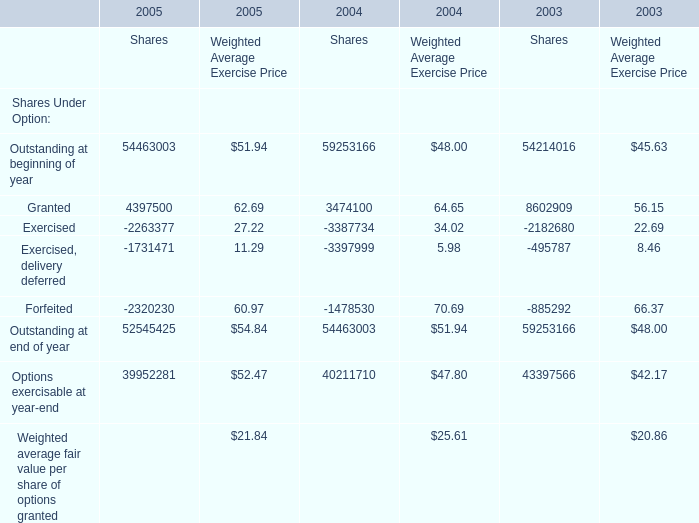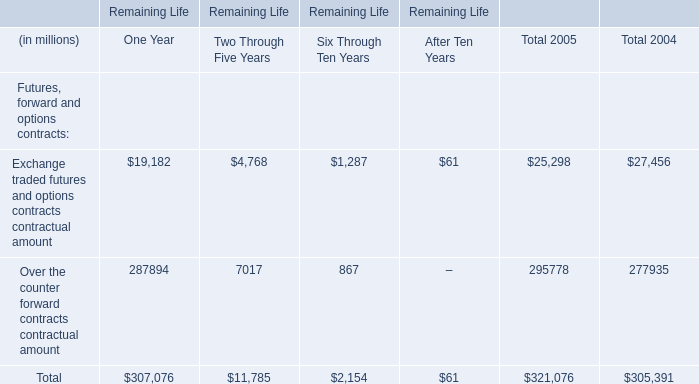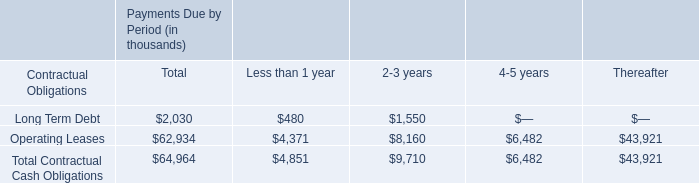What's the average of outstanding at beginning of year and granted and exercised for Shares in 2005? 
Computations: (((54463003 + 4397500) - 2263377) / 3)
Answer: 18865708.66667. 